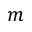<formula> <loc_0><loc_0><loc_500><loc_500>m</formula> 